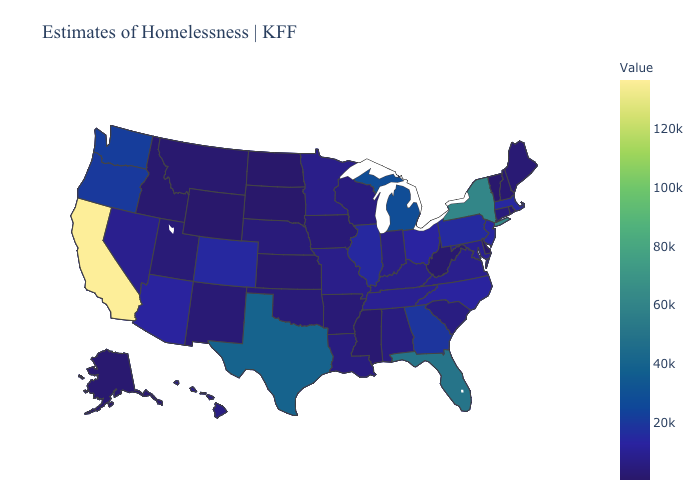Which states have the highest value in the USA?
Quick response, please. California. Does Florida have the highest value in the South?
Be succinct. Yes. Among the states that border Nebraska , does Colorado have the highest value?
Give a very brief answer. Yes. 